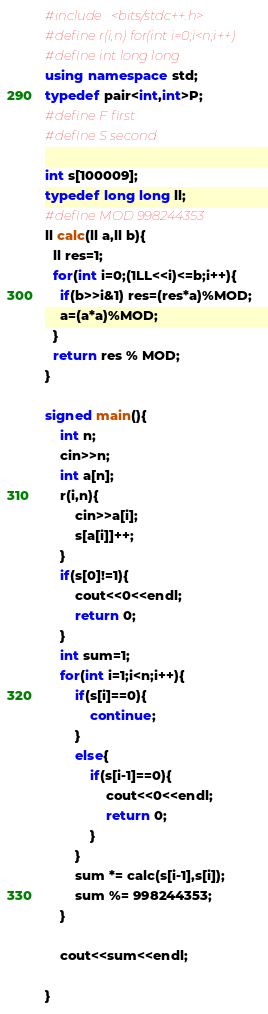<code> <loc_0><loc_0><loc_500><loc_500><_C++_>#include <bits/stdc++.h>
#define r(i,n) for(int i=0;i<n;i++)
#define int long long
using namespace std;
typedef pair<int,int>P;
#define F first
#define S second

int s[100009];
typedef long long ll;
#define MOD 998244353
ll calc(ll a,ll b){
  ll res=1;
  for(int i=0;(1LL<<i)<=b;i++){
    if(b>>i&1) res=(res*a)%MOD;
    a=(a*a)%MOD;
  }
  return res % MOD;
}

signed main(){
	int n;
	cin>>n;
	int a[n];
	r(i,n){
		cin>>a[i];
		s[a[i]]++;
	}
	if(s[0]!=1){
		cout<<0<<endl;
		return 0;
	}
	int sum=1;
	for(int i=1;i<n;i++){
		if(s[i]==0){
			continue;
		}
		else{
			if(s[i-1]==0){
				cout<<0<<endl;
				return 0;
			}
		}
		sum *= calc(s[i-1],s[i]);
		sum %= 998244353;
	}

	cout<<sum<<endl;

}</code> 